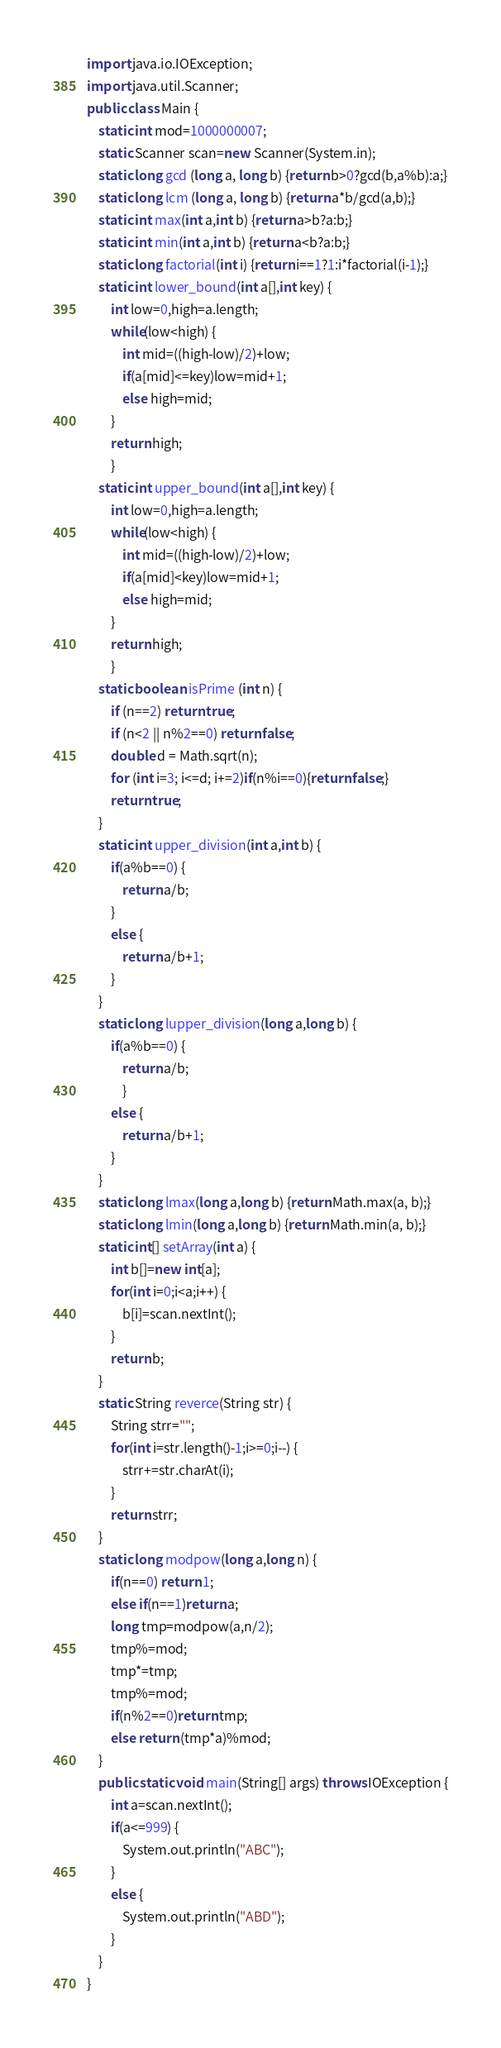<code> <loc_0><loc_0><loc_500><loc_500><_Java_>import java.io.IOException;
import java.util.Scanner;
public class Main {
	static int mod=1000000007;
	static Scanner scan=new Scanner(System.in);
	static long gcd (long a, long b) {return b>0?gcd(b,a%b):a;}
	static long lcm (long a, long b) {return a*b/gcd(a,b);}
	static int max(int a,int b) {return a>b?a:b;}
	static int min(int a,int b) {return a<b?a:b;}
	static long factorial(int i) {return i==1?1:i*factorial(i-1);}
	static int lower_bound(int a[],int key) {
		int low=0,high=a.length;
		while(low<high) {
			int mid=((high-low)/2)+low;
			if(a[mid]<=key)low=mid+1;
			else high=mid;
		}
		return high;
		}
	static int upper_bound(int a[],int key) {
		int low=0,high=a.length;
		while(low<high) {
			int mid=((high-low)/2)+low;
			if(a[mid]<key)low=mid+1;
			else high=mid;
		}
		return high;
		}
	static boolean isPrime (int n) {
		if (n==2) return true;
		if (n<2 || n%2==0) return false;
		double d = Math.sqrt(n);
		for (int i=3; i<=d; i+=2)if(n%i==0){return false;}
		return true;
	}
	static int upper_division(int a,int b) {
		if(a%b==0) {
			return a/b;
		}
		else {
			return a/b+1;
		}
	}
	static long lupper_division(long a,long b) {
		if(a%b==0) {
			return a/b;
			}
		else {
			return a/b+1;
		}
	}
	static long lmax(long a,long b) {return Math.max(a, b);}
	static long lmin(long a,long b) {return Math.min(a, b);}
	static int[] setArray(int a) {
		int b[]=new int[a];
		for(int i=0;i<a;i++) {
			b[i]=scan.nextInt();
		}
		return b;
	}
	static String reverce(String str) {
		String strr="";
		for(int i=str.length()-1;i>=0;i--) {
			strr+=str.charAt(i);
		}
		return strr;
	}
	static long modpow(long a,long n) {
		if(n==0) return 1;
		else if(n==1)return a;
		long tmp=modpow(a,n/2);
		tmp%=mod;
		tmp*=tmp;
		tmp%=mod;
		if(n%2==0)return tmp;
		else return (tmp*a)%mod;
	}
	public static void main(String[] args) throws IOException {
		int a=scan.nextInt();
		if(a<=999) {
			System.out.println("ABC");
		}
		else {
			System.out.println("ABD");
		}
	}
}
</code> 